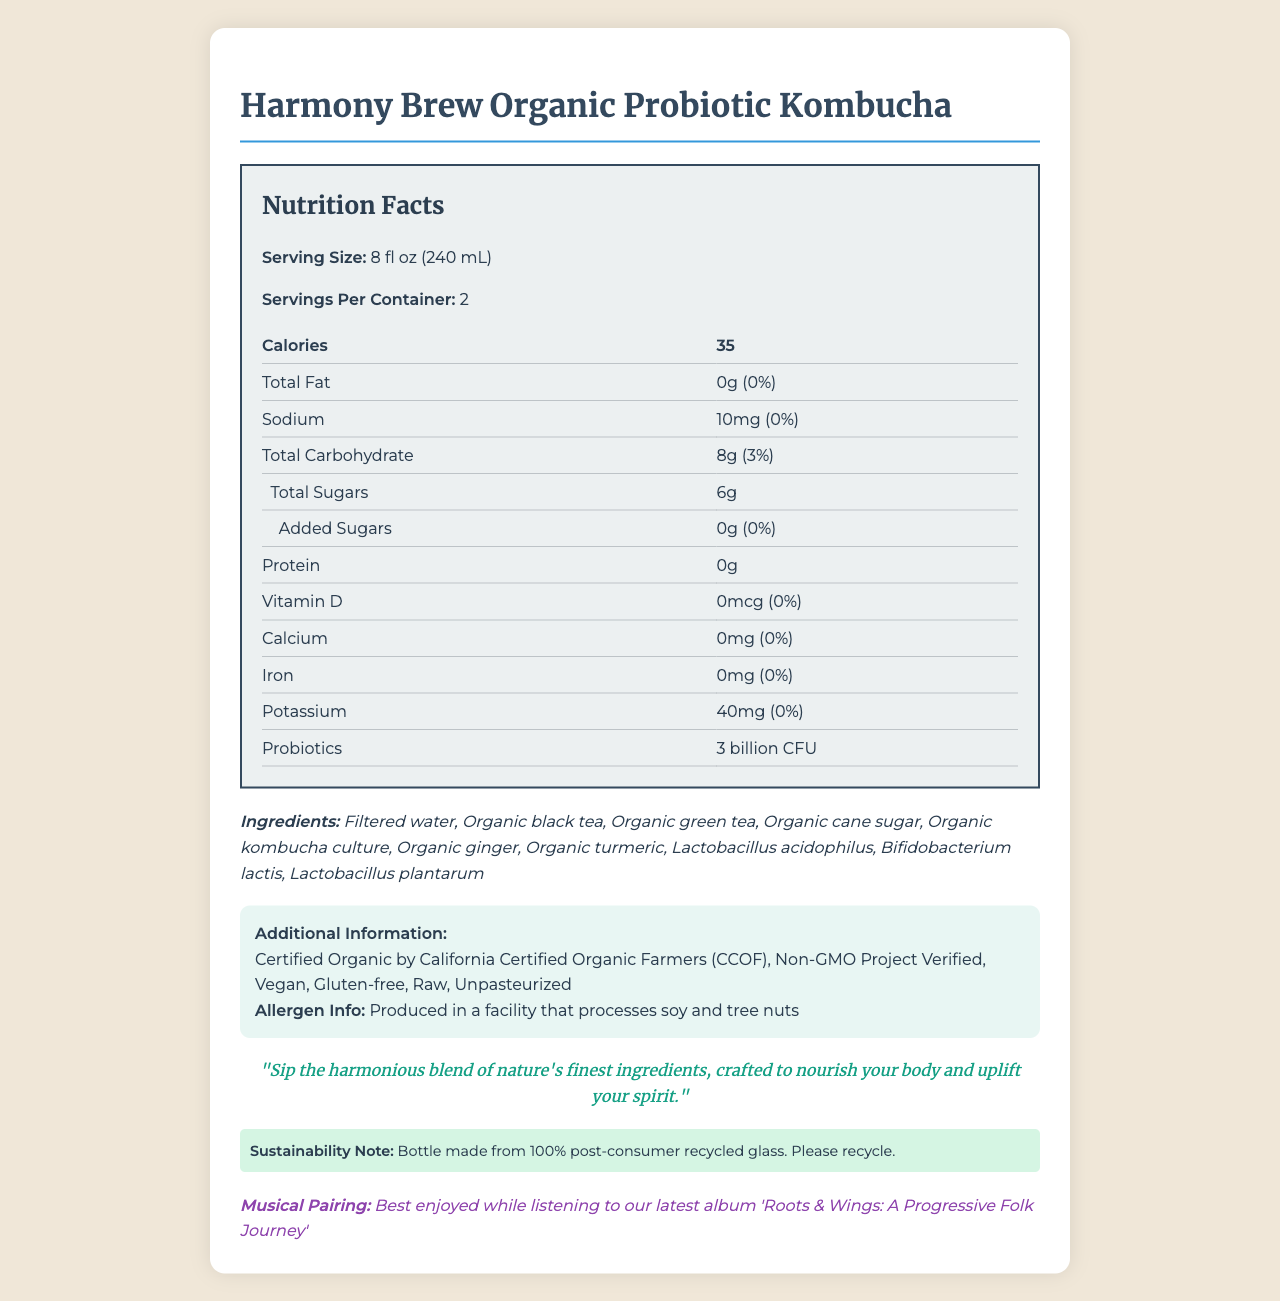What is the serving size? The serving size is listed at the top of the nutrition facts section: "Serving Size: 8 fl oz (240 mL)".
Answer: 8 fl oz (240 mL) How many servings are there per container? The number of servings per container is given as: "Servings Per Container: 2".
Answer: 2 How many calories are there per serving? The nutrition label states: "Calories 35".
Answer: 35 What is the amount of total fat per serving? The label shows: "Total Fat 0g (0%)".
Answer: 0g (0%) What is the amount of sodium per serving? As indicated in the nutrition facts: "Sodium 10mg (0%)".
Answer: 10mg (0%) How many carbohydrates are in one serving? The total carbohydrate value is mentioned as: "Total Carbohydrate 8g (3%)".
Answer: 8g (3%) What is the amount of total sugars in one serving? It says: "Total Sugars 6g".
Answer: 6g Which probiotic bacteria are listed in the ingredients? The ingredients list includes these probiotics: "Lactobacillus acidophilus, Bifidobacterium lactis, Lactobacillus plantarum".
Answer: Lactobacillus acidophilus, Bifidobacterium lactis, Lactobacillus plantarum Does the product contain any added sugars? The label specifically mentions: "Added Sugars 0g (0%)".
Answer: No Which of the following is NOT an ingredient in the kombucha? A. Organic Black Tea B. Organic Cane Sugar C. Artificial Flavors The ingredient list: "Filtered water, Organic black tea, Organic green tea, Organic cane sugar, Organic kombucha culture, Organic ginger, Organic turmeric, Lactobacillus acidophilus, Bifidobacterium lactis, Lactobacillus plantarum". There are no artificial flavors.
Answer: C. Artificial Flavors How much potassium per serving is provided by this kombucha? A. 20mg B. 30mg C. 40mg D. 50mg The nutrition facts specify: "Potassium 40mg (0%)".
Answer: C. 40mg Is the product certified organic? The additional information section confirms: "Certified Organic by California Certified Organic Farmers (CCOF)".
Answer: Yes Does the document provide enough information to determine the source of the probiotics? While the document lists the probiotic strains, it does not specify the source of the probiotics.
Answer: No Summarize the main idea of the document. The document emphasizes the kombucha's organic and health benefits while also engaging with the cultural aspect by suggesting a musical pairing and promoting sustainability.
Answer: The document provides comprehensive nutritional information about Harmony Brew Organic Probiotic Kombucha, highlighting its organic certification, probiotic content, and additional product attributes. It includes serving size, nutritional values, ingredients, allergen information, a folk-inspired tagline, sustainability note, and suggested musical pairing. 